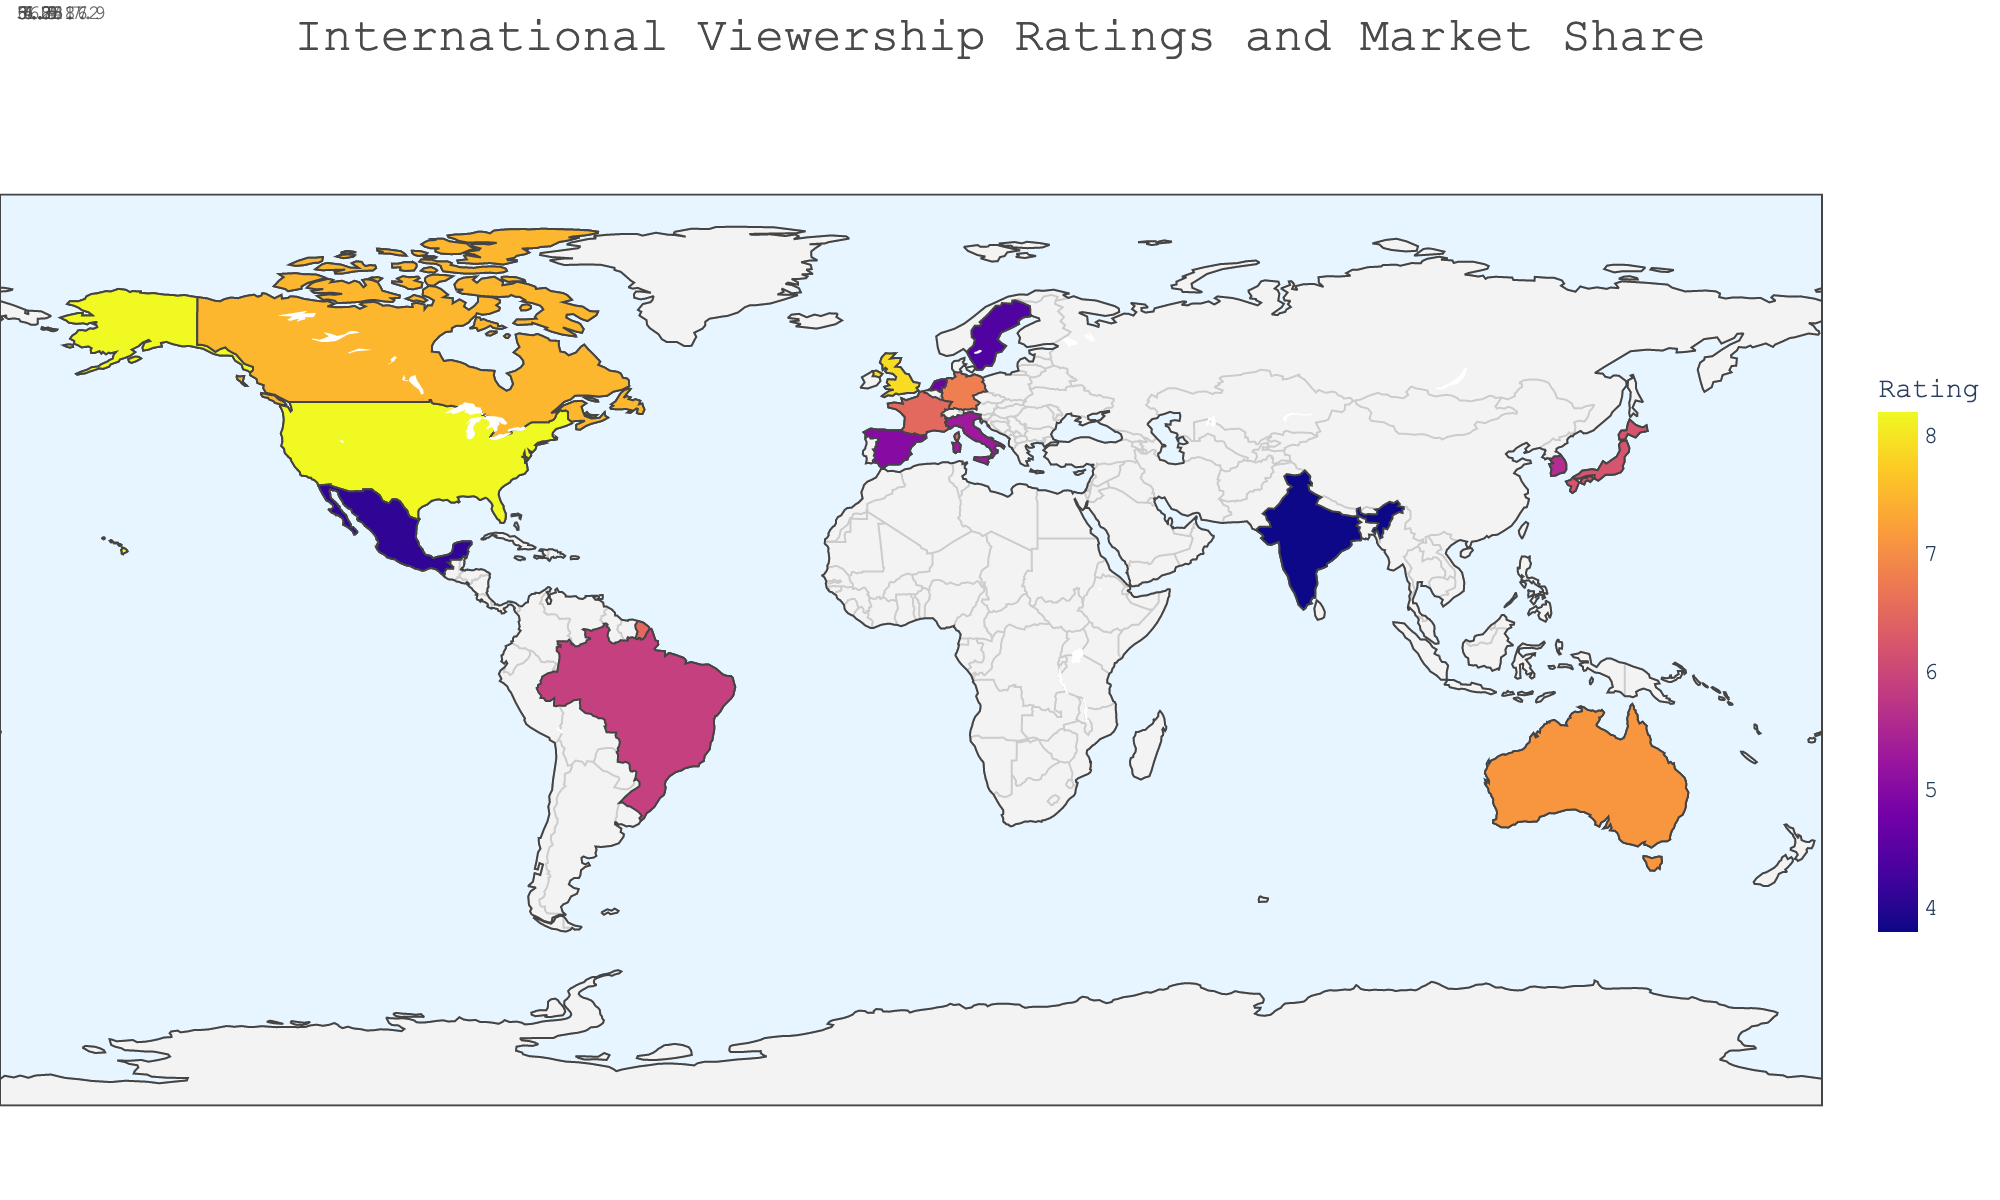What's the title of the plot? The title is usually found at the top of the plot and provides a concise description of what the plot is about. In this case, it can be found at the top and reads "International Viewership Ratings and Market Share."
Answer: International Viewership Ratings and Market Share Which region has the highest viewership rating? The viewership rating is represented by the color intensity on the map, with the highest rating distinctly standing out with the most intense color. From the plot, the United States has the highest viewership rating of 8.2.
Answer: United States What is the market share for Germany? By hovering over Germany on the map, we can see additional details. The market share is mentioned directly in the tooltip data. Germany's market share is 18.2%.
Answer: 18.2% How does the viewership rating of Canada compare to that of Australia? Comparing the color intensity and hovering over both countries, we get their respective viewership ratings: Canada has a rating of 7.5, while Australia has 7.1. Thus, Canada's viewership rating is higher than Australia's.
Answer: Canada's rating is higher What is the average market share of the regions with viewership ratings above 7? First, identify regions with ratings above 7: United States (24.5), United Kingdom (22.1), Canada (20.8), and Australia (19.3). Add their market shares: 24.5 + 22.1 + 20.8 + 19.3 = 86.7. Divide by the number of regions (4): 86.7 / 4 = 21.675%.
Answer: 21.675% How many regions have a viewership rating below 5? Identify the regions with ratings below 5: Netherlands (4.7), Sweden (4.4), Mexico (4.1), and India (3.8). Therefore, there are 4 regions with viewership ratings below 5.
Answer: 4 Which region has the lowest market share, and what is that value? By examining the tooltip data for all regions, we find that India has the lowest market share of 10.2%.
Answer: India, 10.2% Is there a noticeable correlation between viewership ratings and market share? By observing the plot and tooltip data, regions with higher viewership ratings tend to have higher market shares (e.g., United States, United Kingdom, and Canada). This suggests a positive correlation between viewership ratings and market share.
Answer: Yes, positive correlation What is the total market share of the top 3 regions by viewership rating? The top 3 regions by viewership ratings are United States (24.5), United Kingdom (22.1), and Canada (20.8). Summing their market shares: 24.5 + 22.1 + 20.8 = 67.4%.
Answer: 67.4% What is the range of viewership ratings in the plot? The range is determined by finding the difference between the highest and lowest viewership ratings. The highest rating is 8.2 (United States) and the lowest is 3.8 (India). The range is 8.2 - 3.8 = 4.4.
Answer: 4.4 